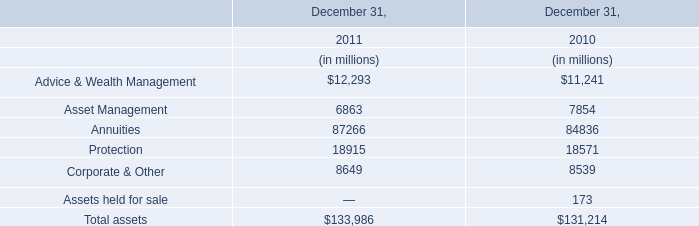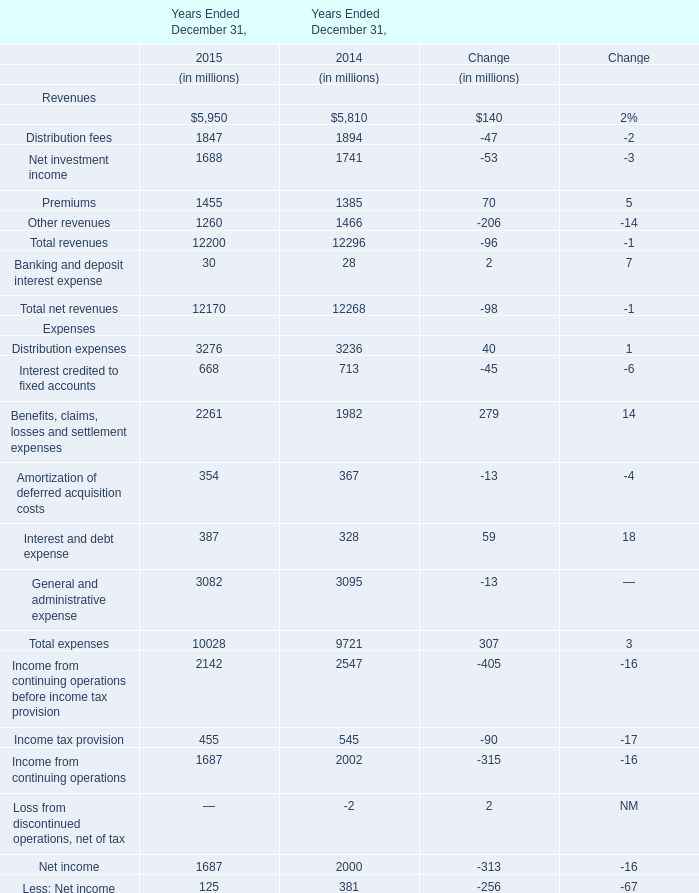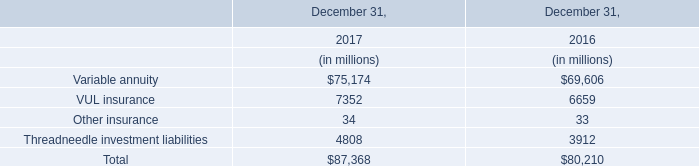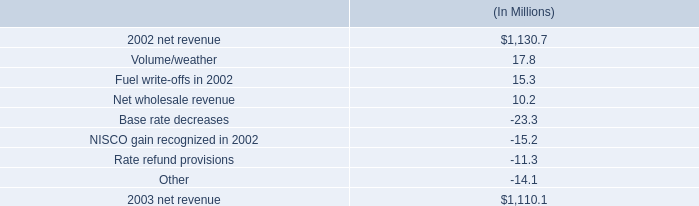In the year with lowest amount of Distribution fees in table 1, what's the increasing rate of Net investment income in table 1? 
Computations: ((1688 - 1741) / 1741)
Answer: -0.03044. 